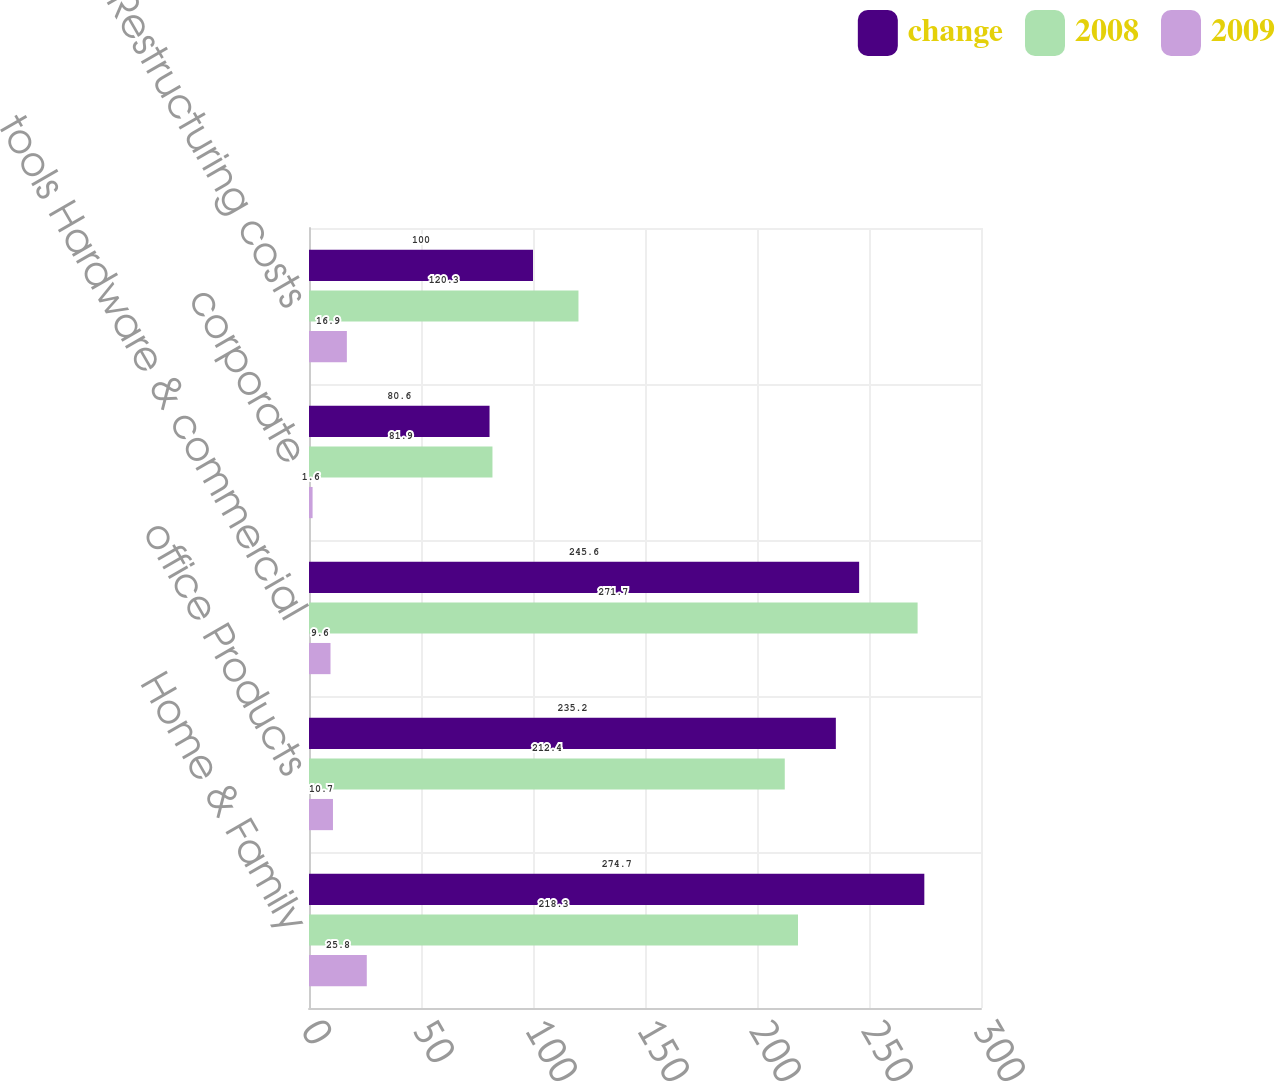Convert chart to OTSL. <chart><loc_0><loc_0><loc_500><loc_500><stacked_bar_chart><ecel><fcel>Home & Family<fcel>office Products<fcel>tools Hardware & commercial<fcel>corporate<fcel>Restructuring costs<nl><fcel>change<fcel>274.7<fcel>235.2<fcel>245.6<fcel>80.6<fcel>100<nl><fcel>2008<fcel>218.3<fcel>212.4<fcel>271.7<fcel>81.9<fcel>120.3<nl><fcel>2009<fcel>25.8<fcel>10.7<fcel>9.6<fcel>1.6<fcel>16.9<nl></chart> 